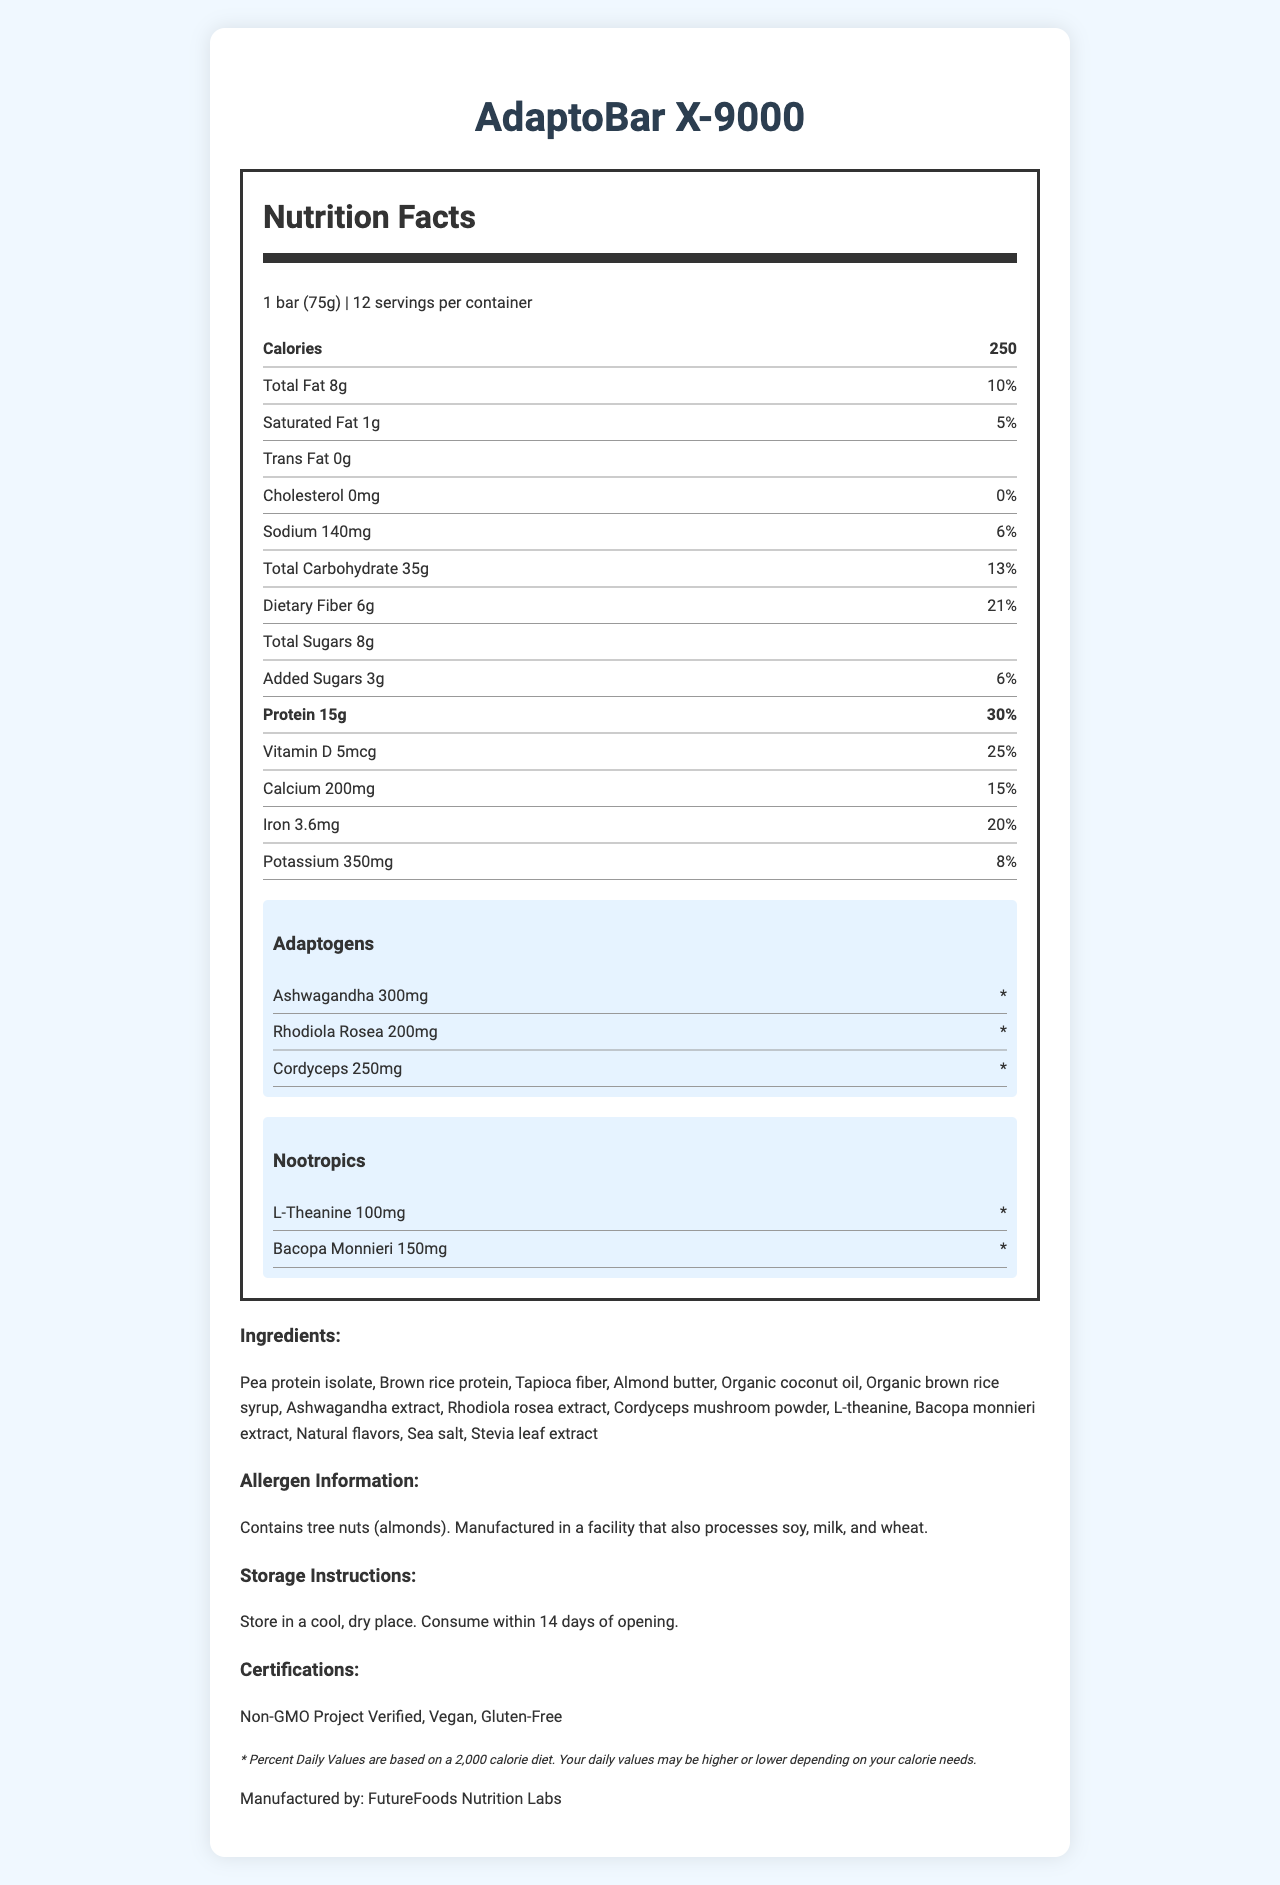what is the serving size of the AdaptoBar X-9000? The serving size is mentioned at the top of the nutrition label beside the "Nutrition Facts" title.
Answer: 1 bar (75g) how many servings are in one container of AdaptoBar X-9000? The number of servings per container is indicated right after the serving size on the nutrition label.
Answer: 12 what is the total fat content per serving? The total fat content is listed in the nutrition label under "Total Fat".
Answer: 8g what percentage of the daily value of protein is in one serving? The daily value percentage of protein is specified beneath the protein amount on the nutrition label.
Answer: 30% how much dietary fiber is in one serving? The dietary fiber content is listed in the nutrition label under "Dietary Fiber".
Answer: 6g which of the following adaptogens is present in the highest amount? A. Ashwagandha B. Rhodiola Rosea C. Cordyceps The amounts of adaptogens listed are Ashwagandha (300mg), Rhodiola Rosea (200mg), and Cordyceps (250mg). Ashwagandha has the highest amount.
Answer: A. Ashwagandha what certification labels are mentioned for AdaptoBar X-9000? A. Organic B. Gluten-Free C. Vegan D. Non-GMO Project Verified The certifications listed in the document are "Non-GMO Project Verified", "Vegan", and "Gluten-Free".
Answer: B, C, and D is there any trans fat in AdaptoBar X-9000? The nutrition facts label indicates that the trans fat content is "0g".
Answer: No how should the AdaptoBar X-9000 be stored once opened? The storage instructions are provided under the "Storage Instructions" section.
Answer: Store in a cool, dry place. Consume within 14 days of opening. list all the nootropics included in the AdaptoBar X-9000. The nootropics are listed under the "Nootropics" section of the label.
Answer: L-Theanine, Bacopa Monnieri what are the adaptogenic properties of the AdaptoBar X-9000 designed to improve? This information is found in the research notes detailing the intended benefits of the adaptogenic blend.
Answer: Stress reduction and cognitive enhancement what is the source of protein in the AdaptoBar X-9000? These protein sources are listed in the ingredients section.
Answer: Pea protein isolate, Brown rice protein summarize the main idea of the AdaptoBar X-9000 nutrition facts document. The document comprehensively covers nutritional content, ingredients, functional components, certifications, and other relevant details essential for consumers.
Answer: The AdaptoBar X-9000 is a meal replacement bar focused on providing a balanced nutrient profile with added adaptogens and nootropics for stress reduction and cognitive enhancement. It contains 250 calories per bar, with detailed information on macronutrient and micronutrient content, as well as certifications such as Non-GMO, Vegan, and Gluten-Free. Ingredients, allergen information, storage instructions, and the manufacturer's information are also provided. what is the clinical efficacy of AdaptoBar X-9000? The document mentions that the product has undergone clinical trials but does not provide specific results or detailed data on clinical efficacy.
Answer: Not enough information 